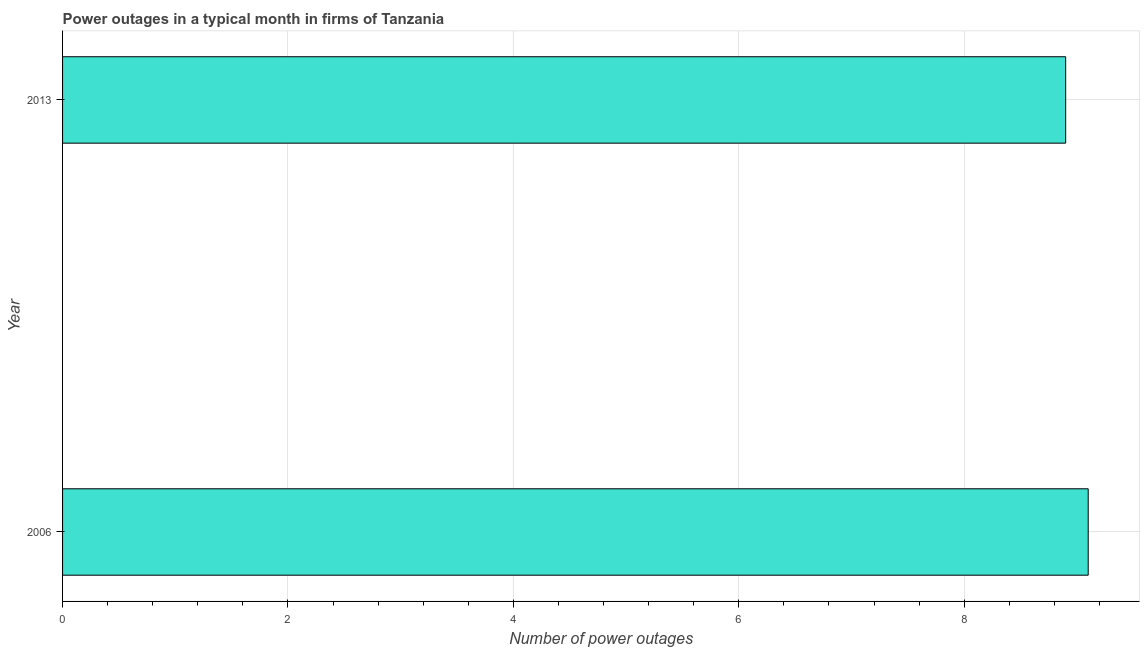Does the graph contain any zero values?
Make the answer very short. No. Does the graph contain grids?
Your answer should be very brief. Yes. What is the title of the graph?
Offer a terse response. Power outages in a typical month in firms of Tanzania. What is the label or title of the X-axis?
Offer a very short reply. Number of power outages. Across all years, what is the maximum number of power outages?
Give a very brief answer. 9.1. Across all years, what is the minimum number of power outages?
Your answer should be compact. 8.9. What is the average number of power outages per year?
Keep it short and to the point. 9. In how many years, is the number of power outages greater than 4 ?
Provide a short and direct response. 2. Do a majority of the years between 2006 and 2013 (inclusive) have number of power outages greater than 6.4 ?
Provide a short and direct response. Yes. Is the number of power outages in 2006 less than that in 2013?
Offer a very short reply. No. How many bars are there?
Your answer should be very brief. 2. Are all the bars in the graph horizontal?
Make the answer very short. Yes. How many years are there in the graph?
Your answer should be compact. 2. What is the difference between two consecutive major ticks on the X-axis?
Offer a terse response. 2. What is the Number of power outages of 2006?
Ensure brevity in your answer.  9.1. What is the Number of power outages in 2013?
Offer a terse response. 8.9. What is the ratio of the Number of power outages in 2006 to that in 2013?
Keep it short and to the point. 1.02. 